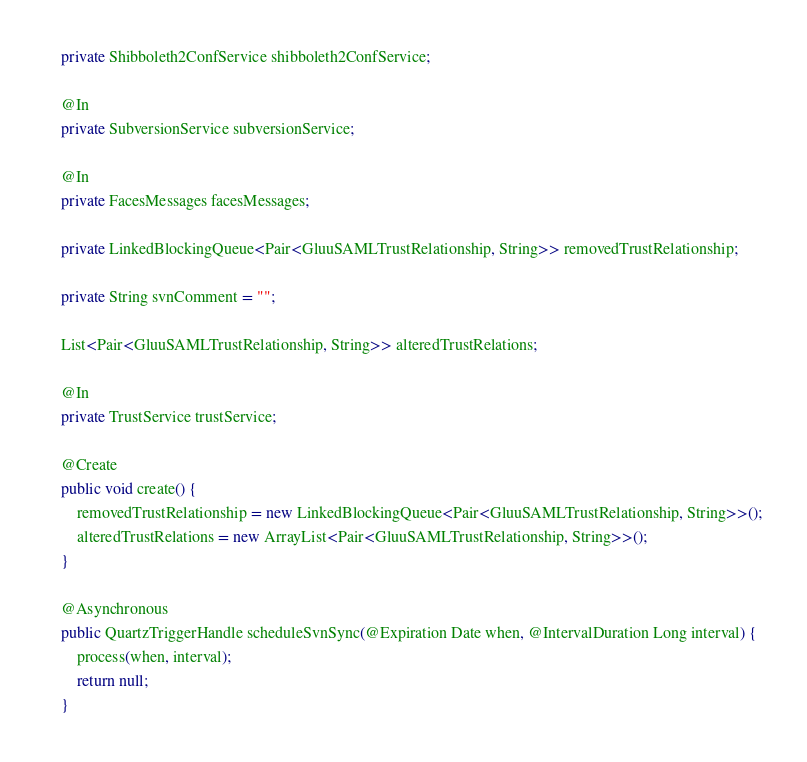<code> <loc_0><loc_0><loc_500><loc_500><_Java_>	private Shibboleth2ConfService shibboleth2ConfService;

	@In
	private SubversionService subversionService;

	@In
	private FacesMessages facesMessages;

	private LinkedBlockingQueue<Pair<GluuSAMLTrustRelationship, String>> removedTrustRelationship;

	private String svnComment = "";

	List<Pair<GluuSAMLTrustRelationship, String>> alteredTrustRelations;

	@In
	private TrustService trustService;

	@Create
	public void create() {
		removedTrustRelationship = new LinkedBlockingQueue<Pair<GluuSAMLTrustRelationship, String>>();
		alteredTrustRelations = new ArrayList<Pair<GluuSAMLTrustRelationship, String>>();
	}

	@Asynchronous
	public QuartzTriggerHandle scheduleSvnSync(@Expiration Date when, @IntervalDuration Long interval) {
		process(when, interval);
		return null;
	}
</code> 